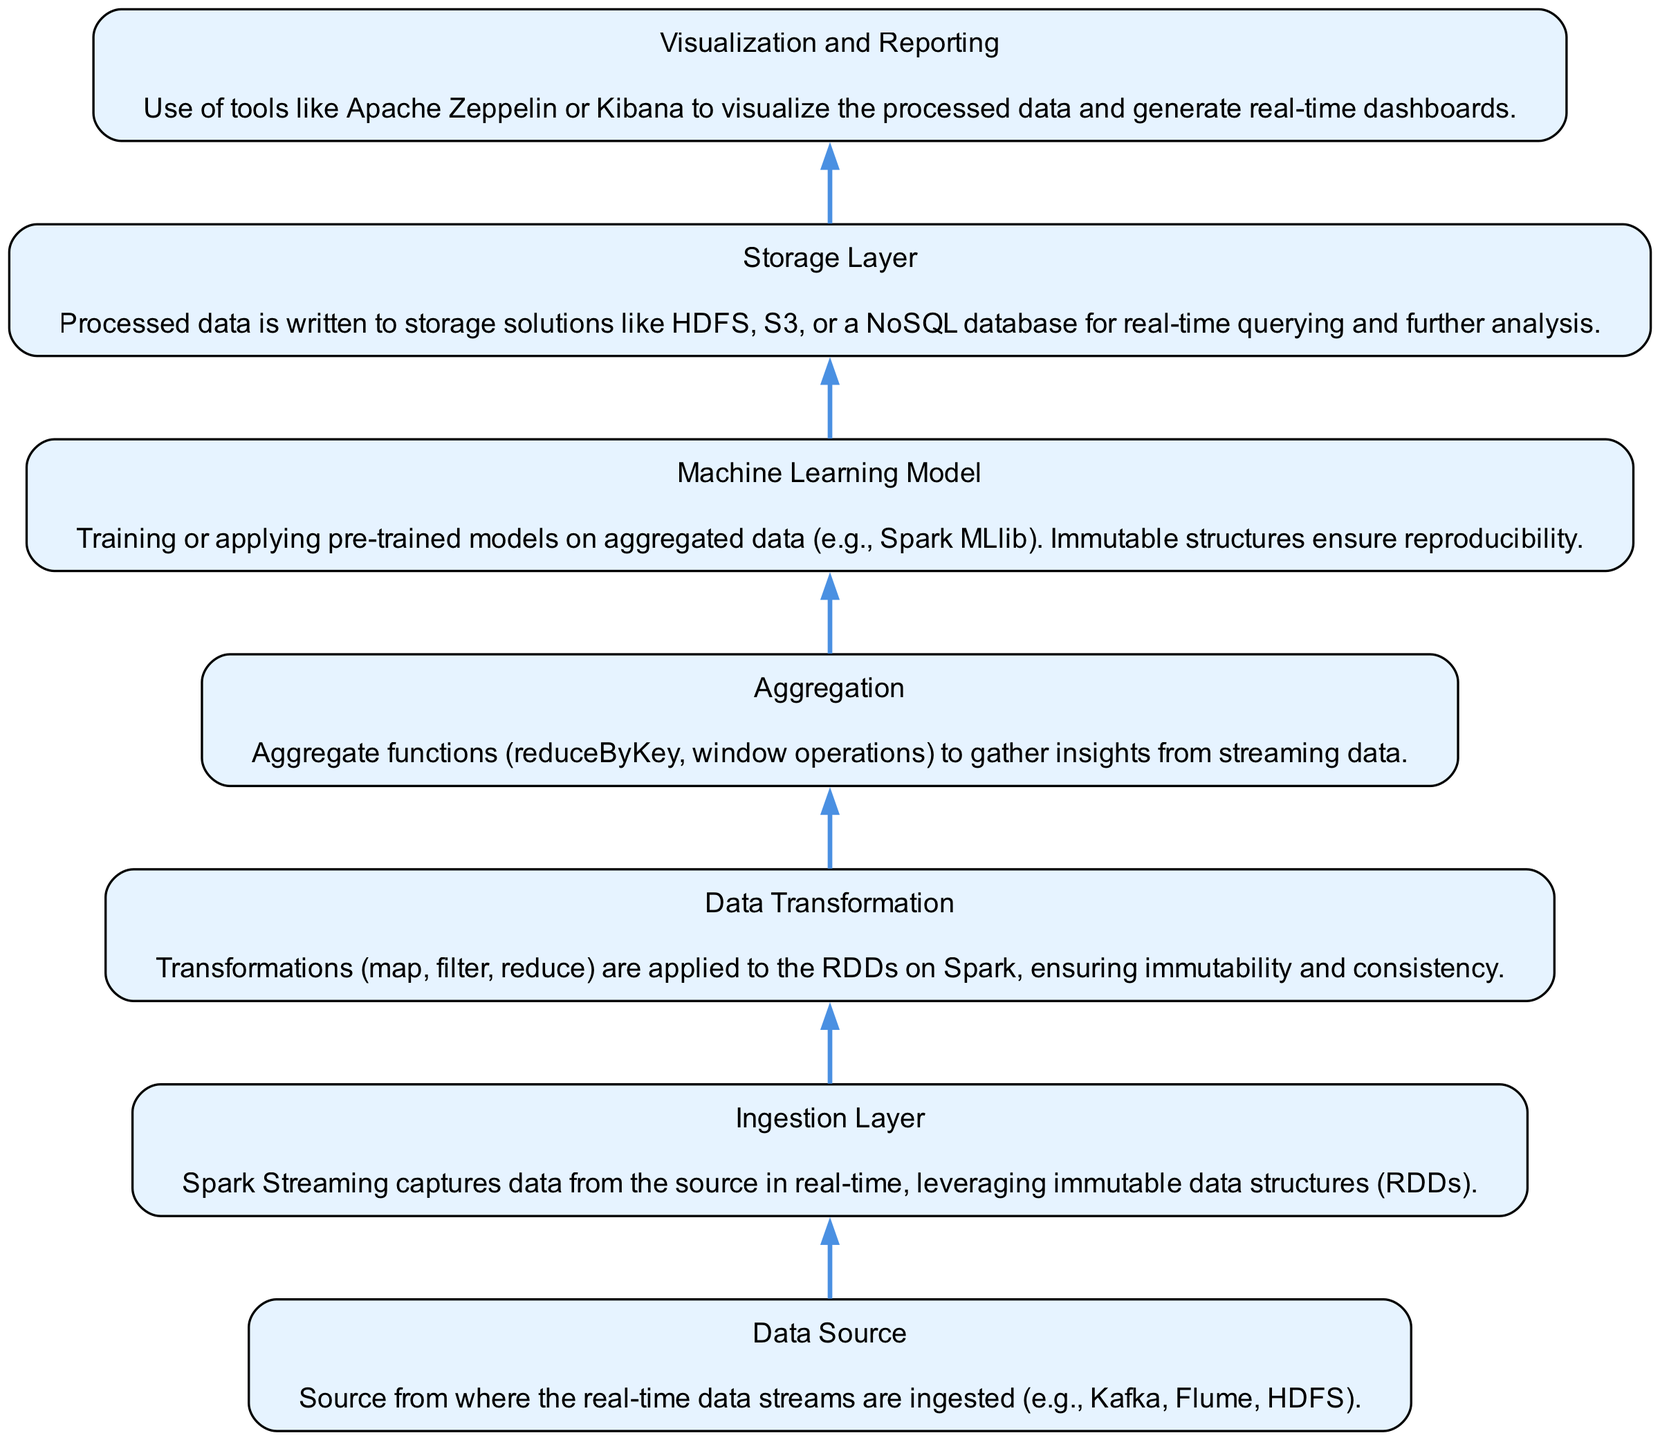What is the top node in the flow chart? The top node in the flow chart is the last step in the data analytics process, which is "Visualization and Reporting." This node represents the final output from the entire pipeline, thus making it the top node in a bottom-to-up flow chart.
Answer: Visualization and Reporting How many nodes are there in the diagram? To find the total number of nodes, we count each unique step in the diagram, which includes: Data Source, Ingestion Layer, Data Transformation, Aggregation, Machine Learning Model, Storage Layer, and Visualization and Reporting. This gives us a total of 7 nodes.
Answer: 7 What node comes immediately after Aggregation? The node immediately after Aggregation in the flow flow upwards is "Machine Learning Model." In the sequential operations, the flow goes from Aggregation to Machine Learning Model, so that is the next step.
Answer: Machine Learning Model Which node follows the Ingestion Layer? In the flow chart, the node that follows the Ingestion Layer is "Data Transformation." This can be verified by following the connections from the Ingestion Layer upwards, leading to the Data Transformation step.
Answer: Data Transformation Which layer is responsible for writing processed data to storage? The layer that writes processed data to storage solutions is the "Storage Layer." In the sequence of operations, this node deals with storing the data for further querying and analysis, placing it in charge of this responsibility.
Answer: Storage Layer What transformation methods are applied after the Ingestion Layer? After the Ingestion Layer, the transformation methods that are applied are "Transformations (map, filter, reduce)." In this context, it indicates the operations that manipulate the streamed data moving forward.
Answer: Transformations (map, filter, reduce) What is the primary function of the Machine Learning Model node? The primary function of the Machine Learning Model node is to train or apply pre-trained models on aggregated data. This step is crucial for deriving insights from the processed data using machine learning algorithms.
Answer: Train or apply models How does the process of data flow in this diagram? The data flow in this diagram moves from the bottom (Data Source) and progresses upwards through discrete layers; each layer processes the data further until the final output is achieved at the top node, Visualization and Reporting. This sequential method illustrates the data analytics pipeline’s organization.
Answer: Bottom to top What is the purpose of using immutable data structures in this process? The purpose of using immutable data structures in the process is to ensure reproducibility. By utilizing immutable data structures like RDDs in Spark, the transformations and results remain consistent and verifiable across processing steps.
Answer: Ensure reproducibility 